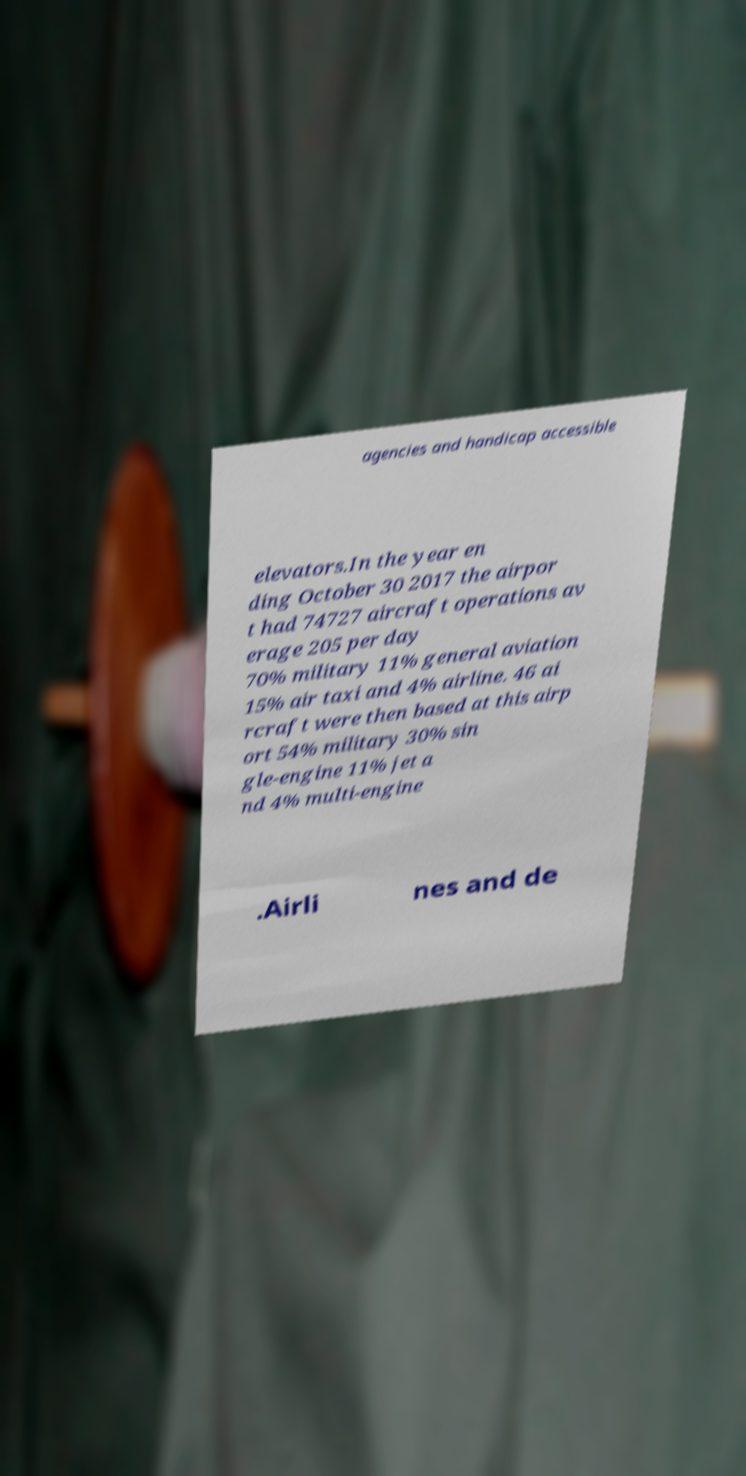What messages or text are displayed in this image? I need them in a readable, typed format. agencies and handicap accessible elevators.In the year en ding October 30 2017 the airpor t had 74727 aircraft operations av erage 205 per day 70% military 11% general aviation 15% air taxi and 4% airline. 46 ai rcraft were then based at this airp ort 54% military 30% sin gle-engine 11% jet a nd 4% multi-engine .Airli nes and de 